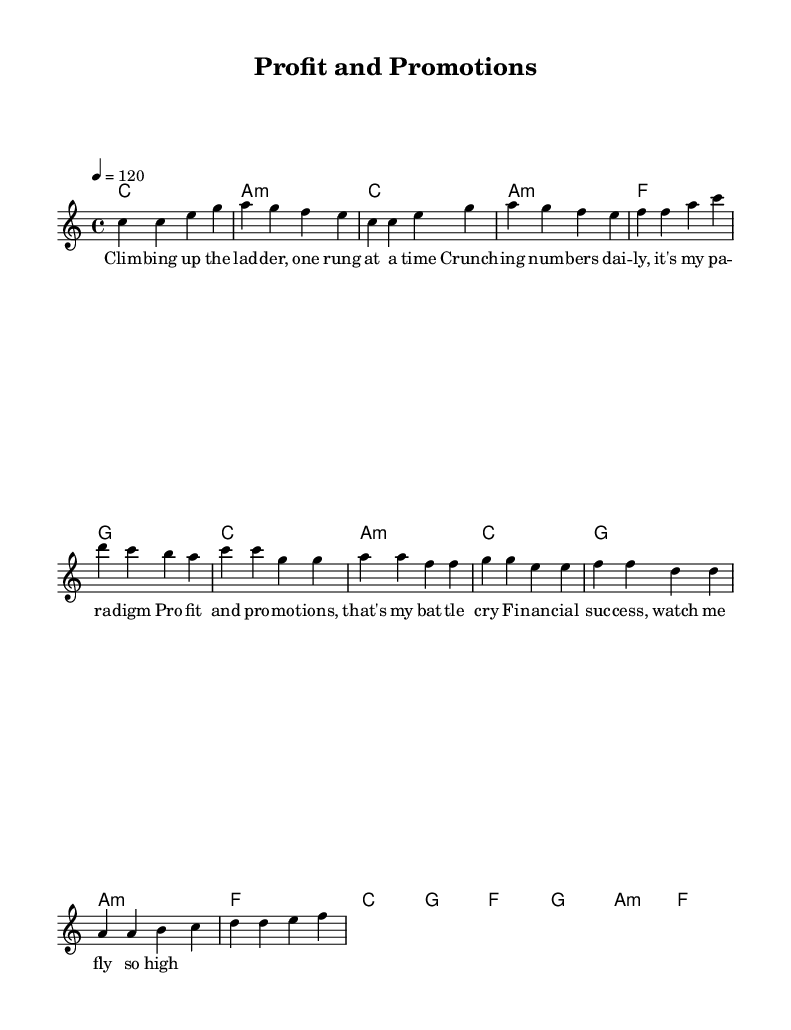What is the key signature of this music? The key signature is set to C major, which has no sharps or flats indicated. This can be found at the beginning of the sheet music.
Answer: C major What is the time signature of this music? The time signature is 4/4, which is indicated at the beginning of the score. This means there are four beats in a measure and the quarter note gets one beat.
Answer: 4/4 What is the tempo marking for this piece? The tempo marking indicates a speed of 120 beats per minute, shown as "4 = 120". This tells musicians to play the piece at this pace.
Answer: 120 How many measures are in the chorus? The chorus consists of eight measures, as counted from the beginning of the chorus lyrics to its end. Each measure is separated by a vertical line on the staff.
Answer: 8 What is the last chord of the piece? The last chord in the bridge section is F major, as indicated in the harmonies at the very end of the musical notation. This can be seen in the chord symbols written above the melody.
Answer: F What is the primary theme of the lyrics? The lyrics primarily focus on financial success and personal advancement in the corporate world, highlighting ambition and determination through phrases like "Profit and promotions."
Answer: Financial success What is the type of this song? This song is classified as an upbeat pop song, as evidenced by its lively melody, tempo, and positive lyrical content centered around themes of success.
Answer: Upbeat pop song 